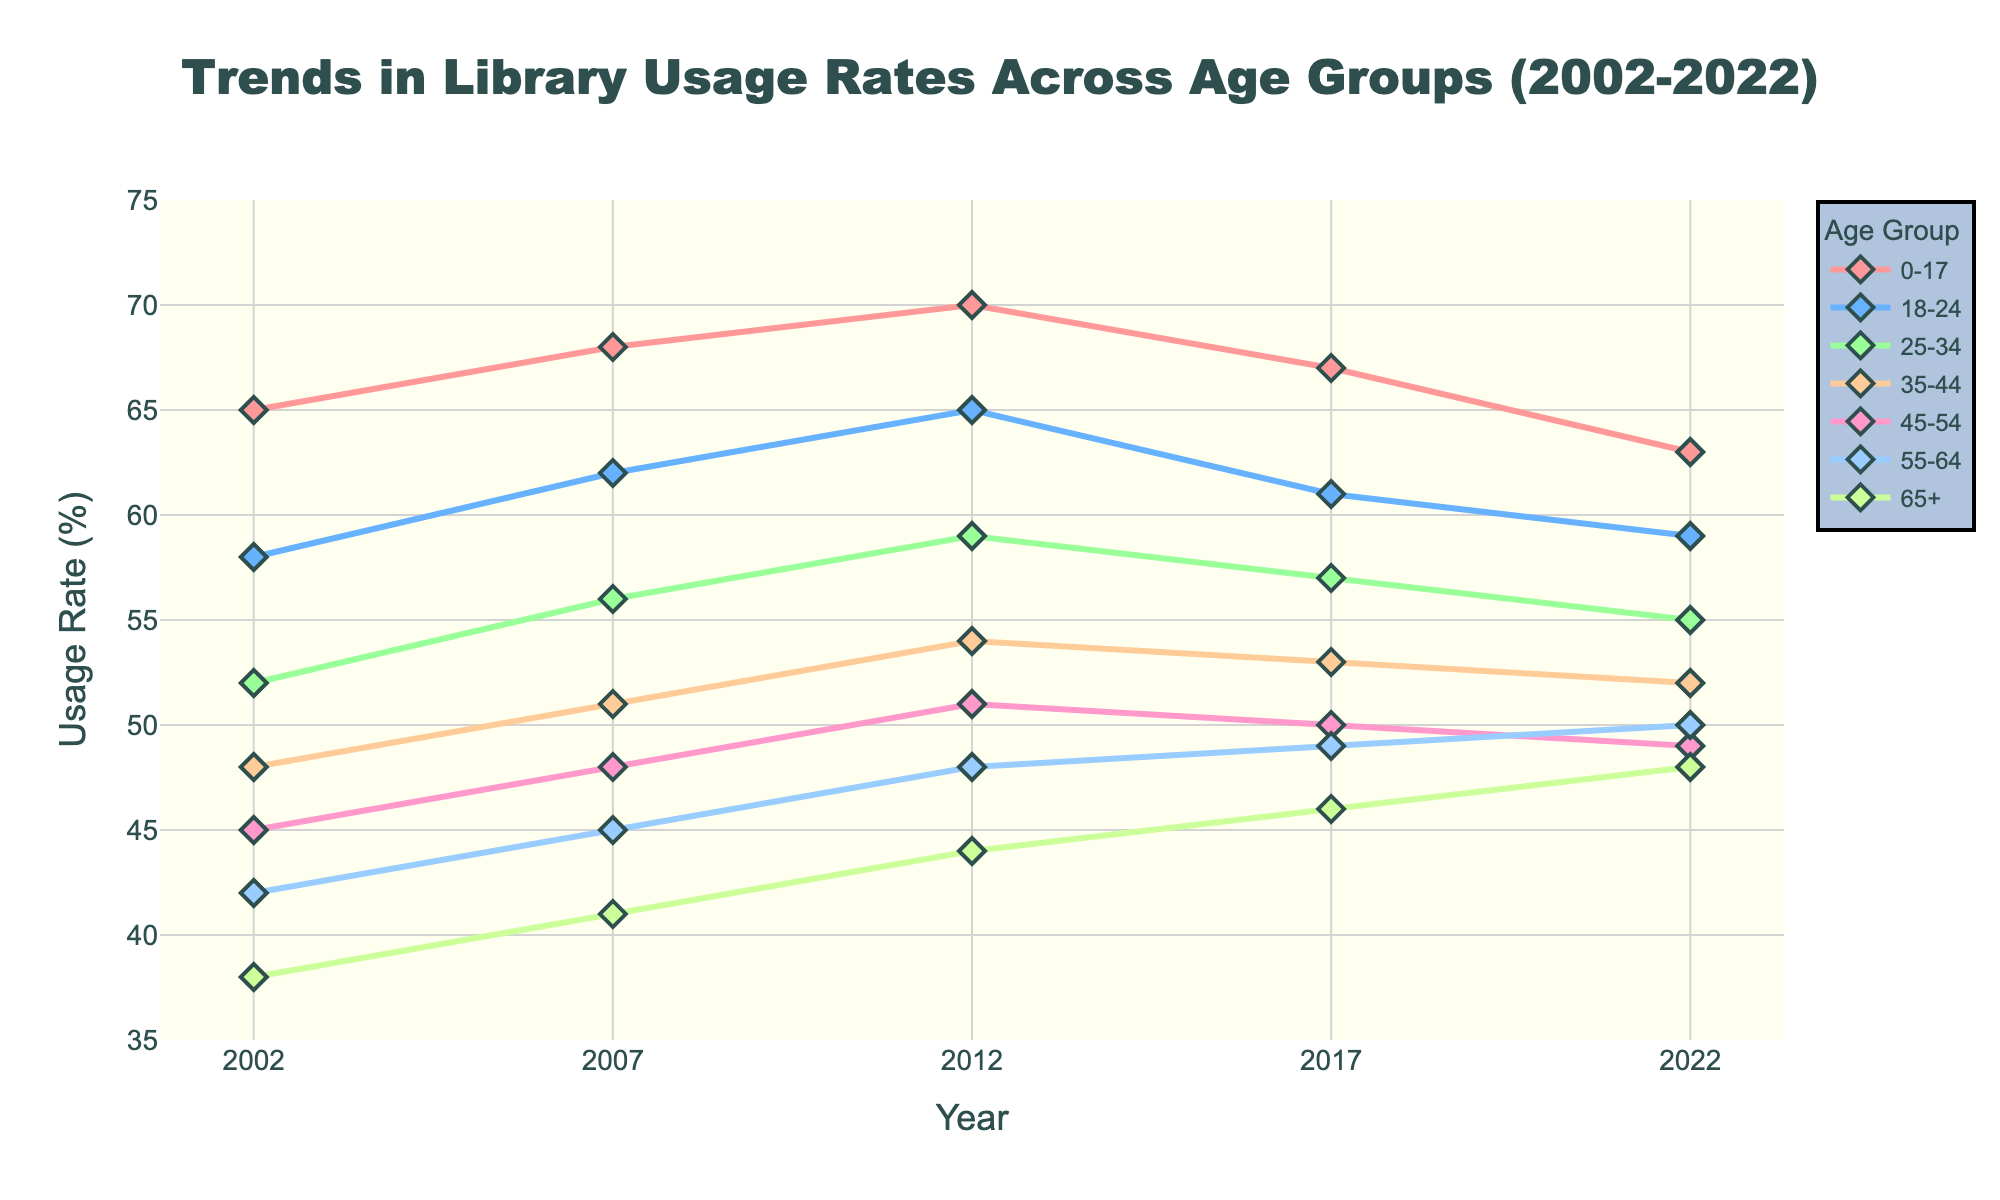How does the usage rate for the 0-17 age group change from 2002 to 2022? First, identify the usage rates for the 0-17 age group in 2002 and 2022 from the chart, which are 65% and 63%, respectively. Subtract the 2022 value from the 2002 value to determine the change, which is 65% - 63% = 2%.
Answer: It decreases by 2% Which age group shows the highest increase in library usage rates between 2002 and 2022? Examine the chart to find the usage rates for all age groups in 2002 and 2022. Calculate the increase for each group by subtracting the 2002 value from the 2022 value: 
- 0-17: 63% - 65% = -2%
- 18-24: 59% - 58% = 1%
- 25-34: 55% - 52% = 3%
- 35-44: 52% - 48% = 4%
- 45-54: 49% - 45% = 4%
- 55-64: 50% - 42% = 8%
- 65+: 48% - 38% = 10%
The 65+ age group has the highest increase of 10%.
Answer: 65+ Which age groups show a continuous increase in usage rates from 2002 to 2022? Check each age group's trend line in the chart. The 55-64 and 65+ age groups show a continuous increase because their usage rates consistently rise in every time period from 2002 to 2022.
Answer: 55-64, 65+ At which year did the 55-64 age group exceed the 45-54 age group in usage rates? Look for the year when the line representing the 55-64 age group crosses above the line for the 45-54 age group. The crossover occurs between 2017 and 2022, so check individual years. In 2017, 55-64 had a usage rate of 49%, and 45-54 had 50%. In 2022, 55-64 had 50%, and 45-54 had 49%. Thus, the crossover occurs in 2022.
Answer: 2022 What is the average usage rate of the 35-44 age group across all years shown? Find the usage rates for the 35-44 age group for all years: 48%, 51%, 54%, 53%, 52%. Sum these values and divide by the number of data points: (48 + 51 + 54 + 53 + 52)/5 = 258/5 = 51.6%.
Answer: 51.6% Which age group starts with a usage rate of less than 50% but ends with a usage rate of over 50%? Examine the initial and final usage rates for all age groups in the chart. The 55-64 age group starts at 42% in 2002 and ends at 50% in 2022.
Answer: 55-64 Which age group shows the highest usage rate in 2022, and what is that rate? By inspecting the chart, find the usage rates for all age groups in 2022. The highest usage rate in 2022 is for the 0-17 age group at 63%.
Answer: 0-17, 63% How many age groups have a usage rate of less than 50% in 2022? Identify usage rates for each age group in 2022 from the chart. Count the number of age groups with rates less than 50%. Only the 35-44, 45-54, and 18-24 groups have rates less than 50% in 2022, resulting in three groups.
Answer: 3 